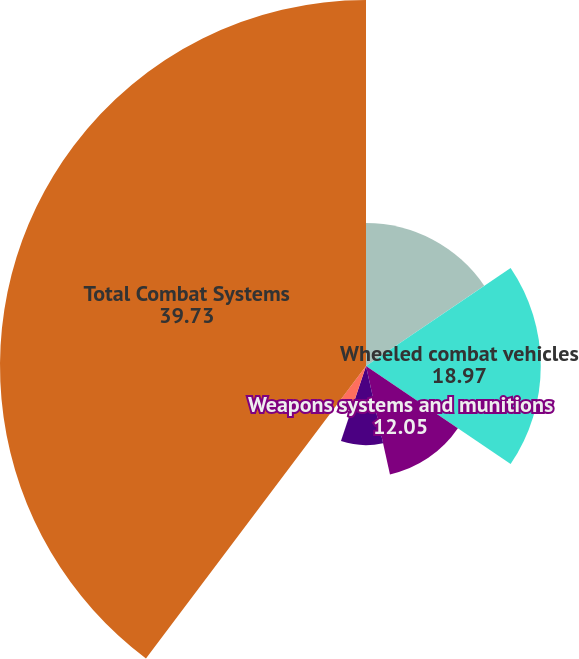Convert chart. <chart><loc_0><loc_0><loc_500><loc_500><pie_chart><fcel>Year Ended December 31<fcel>Wheeled combat vehicles<fcel>Weapons systems and munitions<fcel>Tanks and tracked vehicles<fcel>Engineering and other services<fcel>Total Combat Systems<nl><fcel>15.51%<fcel>18.97%<fcel>12.05%<fcel>8.59%<fcel>5.14%<fcel>39.73%<nl></chart> 